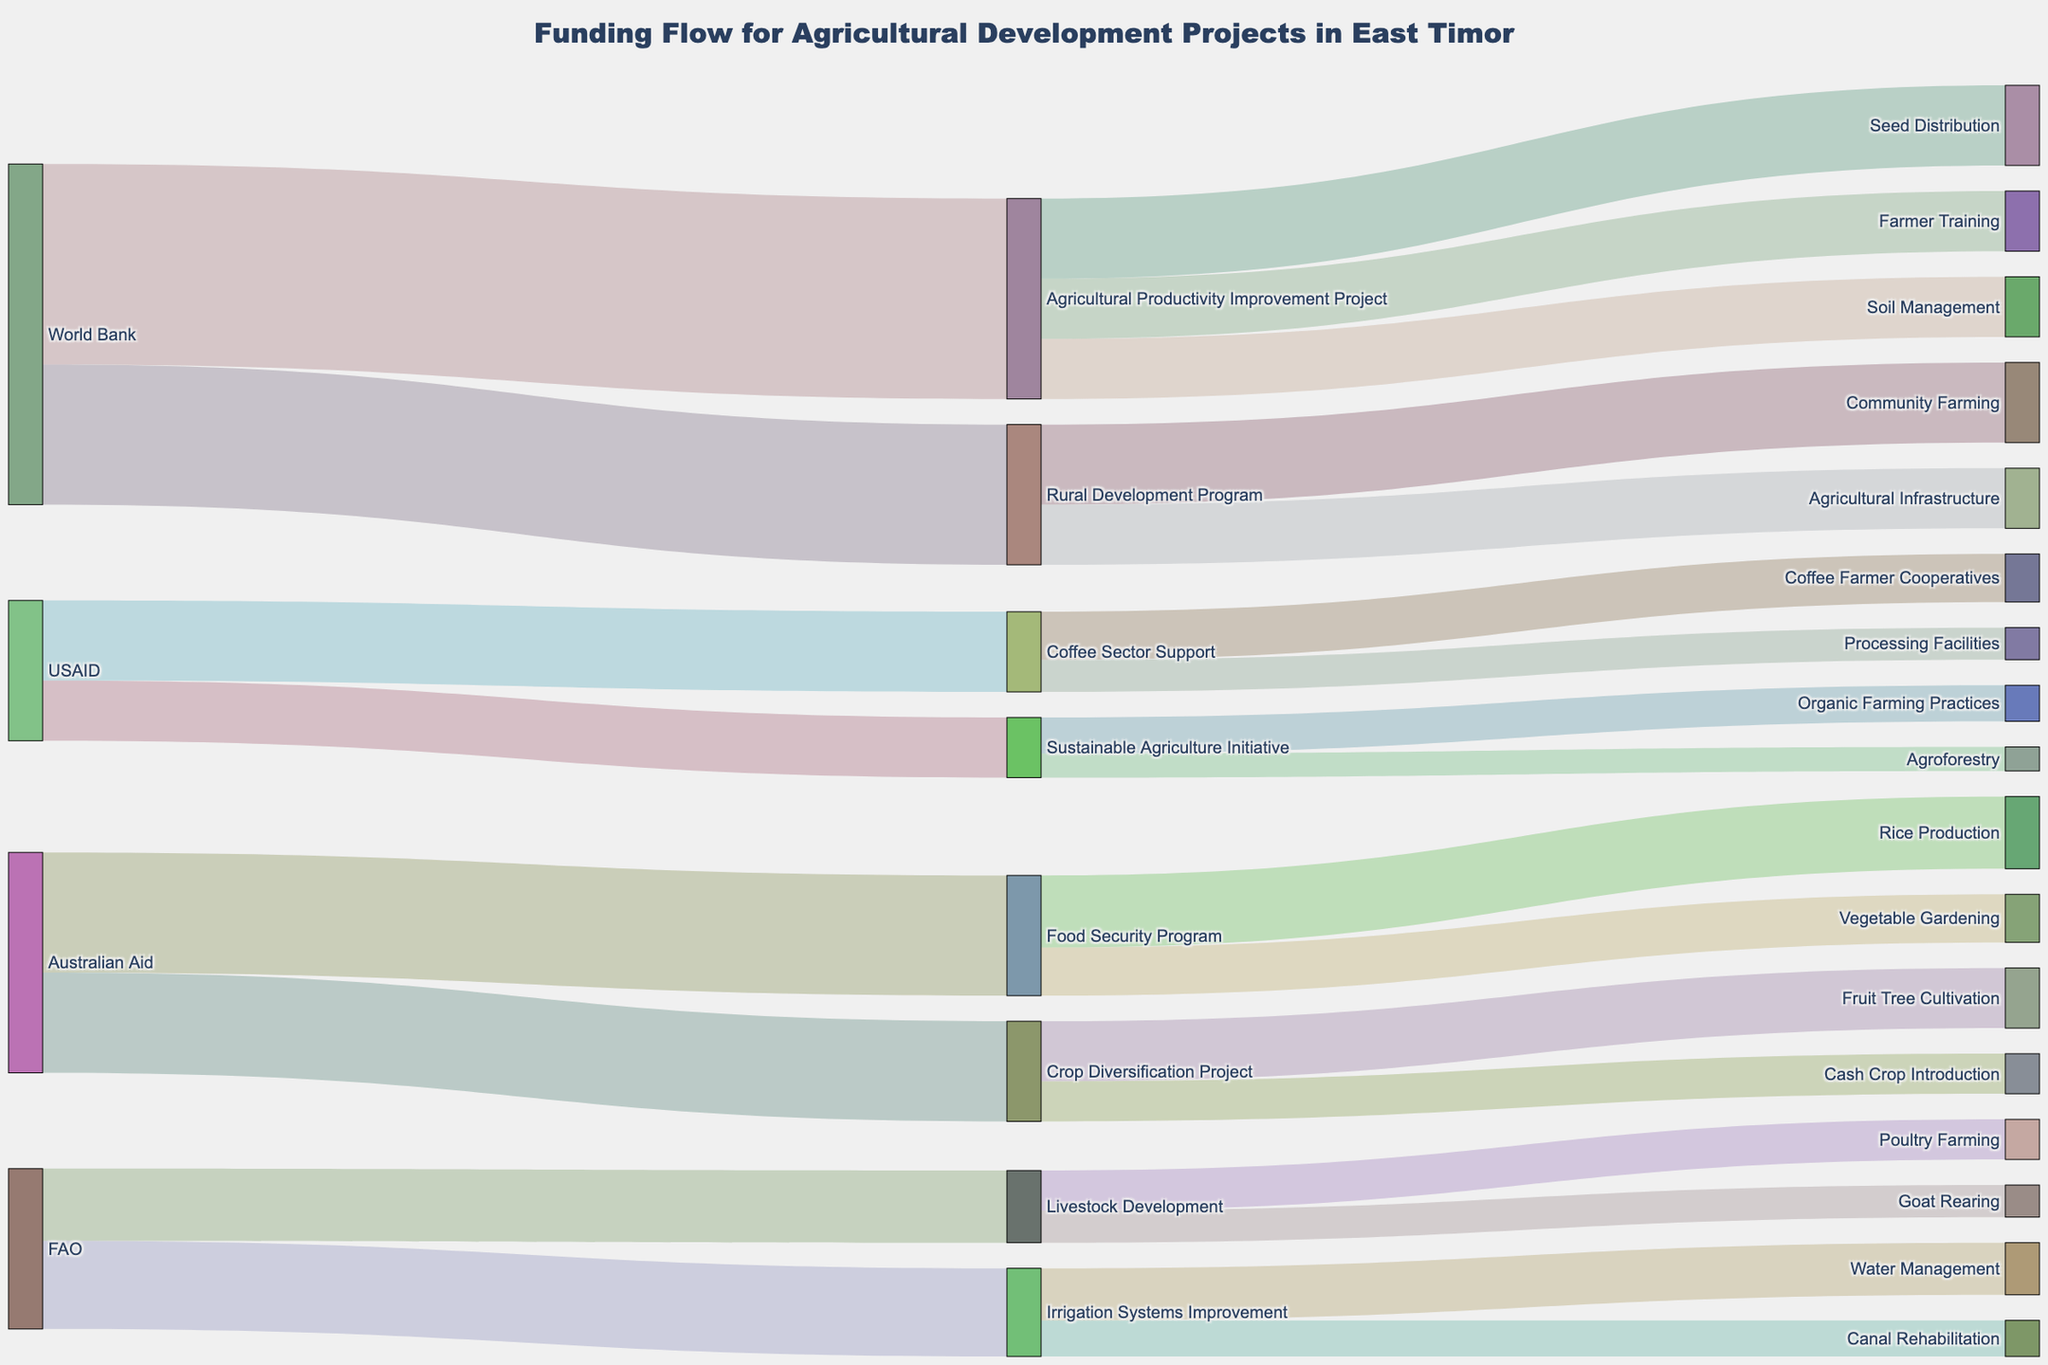What is the title of the Sankey Diagram? The title of the diagram is given at the top of the figure, which provides an overview of the content depicted.
Answer: Funding Flow for Agricultural Development Projects in East Timor Which donor provides the most funding for agricultural projects? By observing the size of the flow from each donor, the World Bank has the largest streams going to its projects.
Answer: World Bank How much total funding does the FAO contribute to agricultural development projects? To find the total funding from FAO, sum the values of all streams originating from FAO: 1,800,000 + 2,200,000 = 4,000,000
Answer: 4,000,000 Compare the funding received by the Agricultural Productivity Improvement Project and the Rural Development Program. Which one receives more funding, and by how much? The Agricultural Productivity Improvement Project receives 5,000,000 and the Rural Development Program receives 3,500,000. The difference is 5,000,000 - 3,500,000 = 1,500,000.
Answer: Agricultural Productivity Improvement Project by 1,500,000 What are the two initiatives under the Sustainable Agriculture Initiative, and how do their funding amounts compare? The two initiatives under the Sustainable Agriculture Initiative are Organic Farming Practices with 900,000 and Agroforestry with 600,000. Organic Farming Practices receives more funding.
Answer: Organic Farming Practices receives more funding Summarize the total funding allocated to projects managed by the World Bank. The World Bank funds the Agricultural Productivity Improvement Project with 5,000,000 and the Rural Development Program with 3,500,000. The total is 5,000,000 + 3,500,000 = 8,500,000.
Answer: 8,500,000 Which initiative under the Livestock Development program receives less funding and by how much? The Livestock Development program has two initiatives: Poultry Farming with 1,000,000 and Goat Rearing with 800,000. Goat Rearing receives less funding by 1,000,000 - 800,000 = 200,000.
Answer: Goat Rearing by 200,000 From which donors does the Crop Diversification Project receive its funding, and what is the total amount? The Crop Diversification Project receives 2,500,000 from Australian Aid.
Answer: Australian Aid, 2,500,000 Compare the total funding received by Rice Production and Vegetable Gardening initiatives under the Food Security Program. Which one receives more, and what is the funding difference? Rice Production receives 1,800,000, and Vegetable Gardening receives 1,200,000. Rice Production receives more funding by 1,800,000 - 1,200,000 = 600,000.
Answer: Rice Production by 600,000 